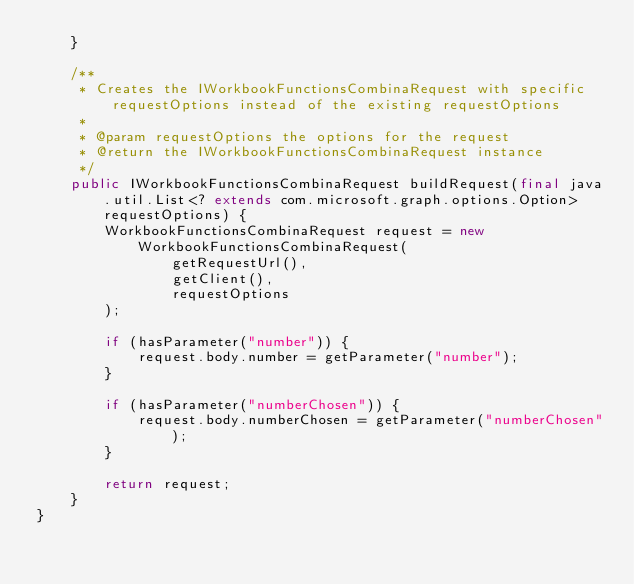Convert code to text. <code><loc_0><loc_0><loc_500><loc_500><_Java_>    }

    /**
     * Creates the IWorkbookFunctionsCombinaRequest with specific requestOptions instead of the existing requestOptions
     *
     * @param requestOptions the options for the request
     * @return the IWorkbookFunctionsCombinaRequest instance
     */
    public IWorkbookFunctionsCombinaRequest buildRequest(final java.util.List<? extends com.microsoft.graph.options.Option> requestOptions) {
        WorkbookFunctionsCombinaRequest request = new WorkbookFunctionsCombinaRequest(
                getRequestUrl(),
                getClient(),
                requestOptions
        );

        if (hasParameter("number")) {
            request.body.number = getParameter("number");
        }

        if (hasParameter("numberChosen")) {
            request.body.numberChosen = getParameter("numberChosen");
        }

        return request;
    }
}
</code> 